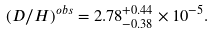Convert formula to latex. <formula><loc_0><loc_0><loc_500><loc_500>( D / H ) ^ { o b s } = 2 . 7 8 _ { - 0 . 3 8 } ^ { + 0 . 4 4 } \times 1 0 ^ { - 5 } .</formula> 